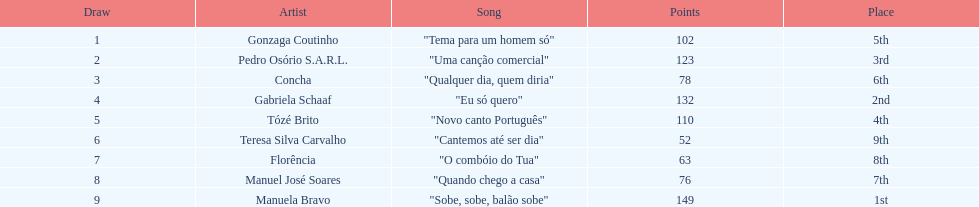Who delivered "eu só quero" as their melody during the 1979 eurovision song contest? Gabriela Schaaf. 